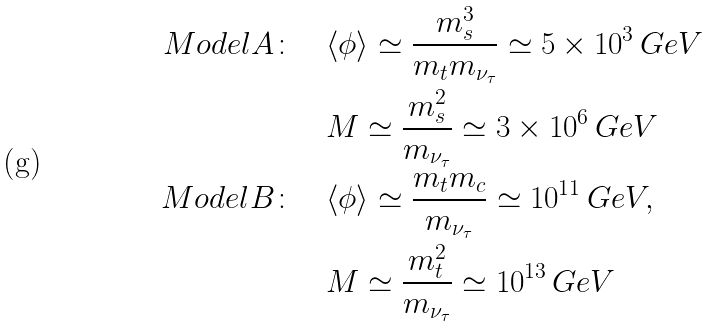Convert formula to latex. <formula><loc_0><loc_0><loc_500><loc_500>M o d e l A \colon \quad & \langle \phi \rangle \simeq \frac { m _ { s } ^ { 3 } } { m _ { t } m _ { \nu _ { \tau } } } \simeq 5 \times 1 0 ^ { 3 } \, G e V \\ & M \simeq \frac { m _ { s } ^ { 2 } } { m _ { \nu _ { \tau } } } \simeq 3 \times 1 0 ^ { 6 } \, G e V \\ M o d e l B \colon \quad & \langle \phi \rangle \simeq \frac { m _ { t } m _ { c } } { m _ { \nu _ { \tau } } } \simeq 1 0 ^ { 1 1 } \, G e V , \\ & M \simeq \frac { m _ { t } ^ { 2 } } { m _ { \nu _ { \tau } } } \simeq 1 0 ^ { 1 3 } \, G e V</formula> 